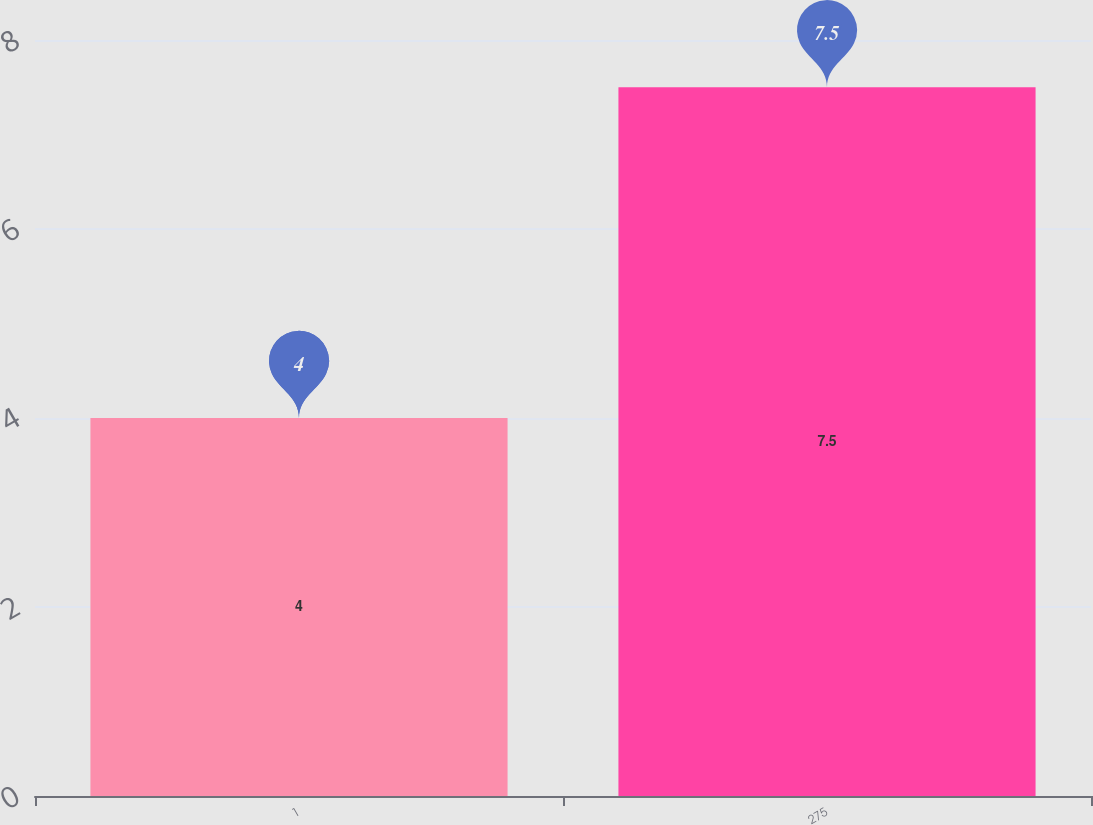Convert chart to OTSL. <chart><loc_0><loc_0><loc_500><loc_500><bar_chart><fcel>1<fcel>275<nl><fcel>4<fcel>7.5<nl></chart> 